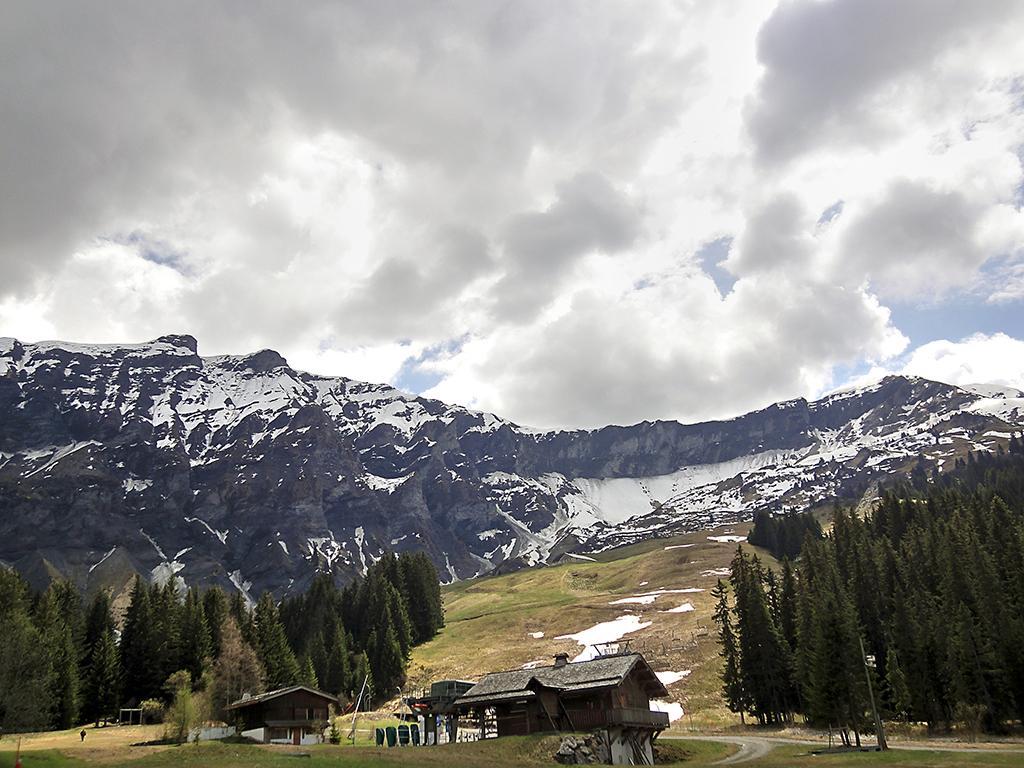Can you describe this image briefly? At the foreground of the image there are some houses, road and at the background of the image there are some alpine trees, snow mountains and cloudy sky. 